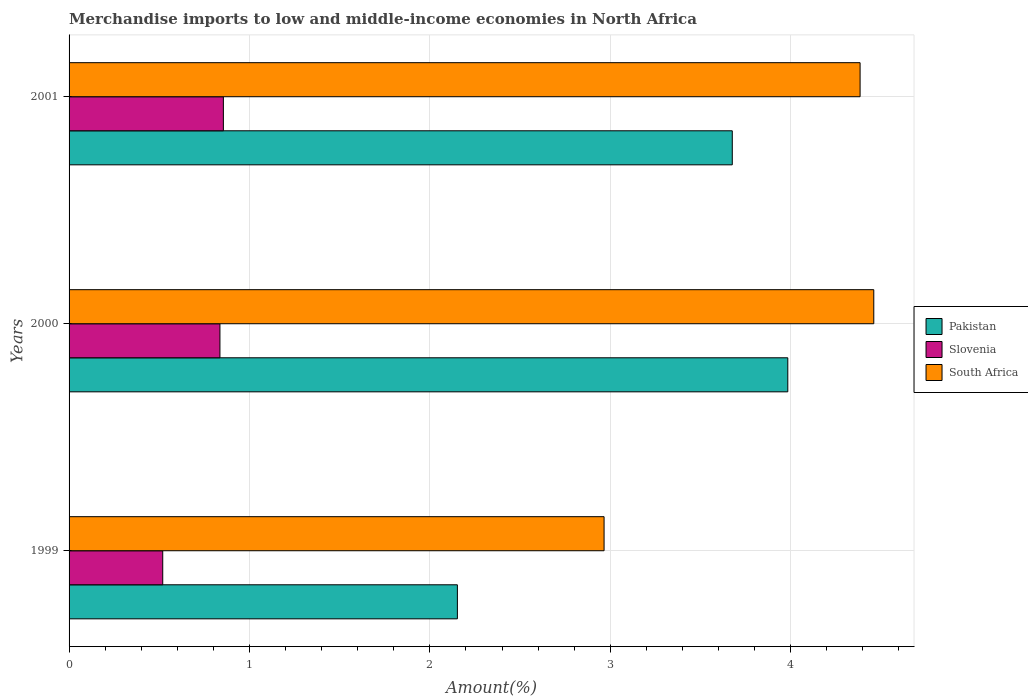How many groups of bars are there?
Offer a terse response. 3. Are the number of bars per tick equal to the number of legend labels?
Provide a short and direct response. Yes. How many bars are there on the 3rd tick from the bottom?
Provide a succinct answer. 3. What is the percentage of amount earned from merchandise imports in Slovenia in 2000?
Make the answer very short. 0.84. Across all years, what is the maximum percentage of amount earned from merchandise imports in Pakistan?
Offer a terse response. 3.98. Across all years, what is the minimum percentage of amount earned from merchandise imports in South Africa?
Provide a short and direct response. 2.97. In which year was the percentage of amount earned from merchandise imports in Slovenia maximum?
Your answer should be very brief. 2001. In which year was the percentage of amount earned from merchandise imports in Pakistan minimum?
Your answer should be compact. 1999. What is the total percentage of amount earned from merchandise imports in South Africa in the graph?
Your answer should be very brief. 11.81. What is the difference between the percentage of amount earned from merchandise imports in Slovenia in 1999 and that in 2001?
Offer a very short reply. -0.34. What is the difference between the percentage of amount earned from merchandise imports in Slovenia in 2000 and the percentage of amount earned from merchandise imports in South Africa in 2001?
Your answer should be compact. -3.55. What is the average percentage of amount earned from merchandise imports in Slovenia per year?
Provide a short and direct response. 0.74. In the year 1999, what is the difference between the percentage of amount earned from merchandise imports in Pakistan and percentage of amount earned from merchandise imports in South Africa?
Your response must be concise. -0.81. In how many years, is the percentage of amount earned from merchandise imports in South Africa greater than 1.6 %?
Provide a short and direct response. 3. What is the ratio of the percentage of amount earned from merchandise imports in Pakistan in 1999 to that in 2001?
Make the answer very short. 0.59. Is the percentage of amount earned from merchandise imports in Pakistan in 1999 less than that in 2001?
Provide a succinct answer. Yes. Is the difference between the percentage of amount earned from merchandise imports in Pakistan in 1999 and 2001 greater than the difference between the percentage of amount earned from merchandise imports in South Africa in 1999 and 2001?
Make the answer very short. No. What is the difference between the highest and the second highest percentage of amount earned from merchandise imports in Pakistan?
Offer a terse response. 0.31. What is the difference between the highest and the lowest percentage of amount earned from merchandise imports in Slovenia?
Your answer should be very brief. 0.34. What does the 1st bar from the top in 2001 represents?
Offer a terse response. South Africa. What does the 3rd bar from the bottom in 1999 represents?
Your answer should be very brief. South Africa. Is it the case that in every year, the sum of the percentage of amount earned from merchandise imports in South Africa and percentage of amount earned from merchandise imports in Pakistan is greater than the percentage of amount earned from merchandise imports in Slovenia?
Offer a very short reply. Yes. Are all the bars in the graph horizontal?
Give a very brief answer. Yes. How many years are there in the graph?
Ensure brevity in your answer.  3. Are the values on the major ticks of X-axis written in scientific E-notation?
Provide a succinct answer. No. Does the graph contain any zero values?
Provide a short and direct response. No. Does the graph contain grids?
Ensure brevity in your answer.  Yes. How are the legend labels stacked?
Ensure brevity in your answer.  Vertical. What is the title of the graph?
Offer a very short reply. Merchandise imports to low and middle-income economies in North Africa. Does "Paraguay" appear as one of the legend labels in the graph?
Your answer should be compact. No. What is the label or title of the X-axis?
Ensure brevity in your answer.  Amount(%). What is the Amount(%) of Pakistan in 1999?
Provide a short and direct response. 2.15. What is the Amount(%) of Slovenia in 1999?
Your response must be concise. 0.52. What is the Amount(%) in South Africa in 1999?
Offer a terse response. 2.97. What is the Amount(%) of Pakistan in 2000?
Give a very brief answer. 3.98. What is the Amount(%) in Slovenia in 2000?
Keep it short and to the point. 0.84. What is the Amount(%) of South Africa in 2000?
Offer a terse response. 4.46. What is the Amount(%) in Pakistan in 2001?
Give a very brief answer. 3.68. What is the Amount(%) in Slovenia in 2001?
Give a very brief answer. 0.86. What is the Amount(%) in South Africa in 2001?
Your response must be concise. 4.38. Across all years, what is the maximum Amount(%) in Pakistan?
Offer a very short reply. 3.98. Across all years, what is the maximum Amount(%) in Slovenia?
Provide a short and direct response. 0.86. Across all years, what is the maximum Amount(%) in South Africa?
Provide a short and direct response. 4.46. Across all years, what is the minimum Amount(%) in Pakistan?
Your response must be concise. 2.15. Across all years, what is the minimum Amount(%) in Slovenia?
Offer a very short reply. 0.52. Across all years, what is the minimum Amount(%) in South Africa?
Ensure brevity in your answer.  2.97. What is the total Amount(%) of Pakistan in the graph?
Provide a short and direct response. 9.81. What is the total Amount(%) in Slovenia in the graph?
Keep it short and to the point. 2.21. What is the total Amount(%) of South Africa in the graph?
Ensure brevity in your answer.  11.81. What is the difference between the Amount(%) in Pakistan in 1999 and that in 2000?
Your answer should be compact. -1.83. What is the difference between the Amount(%) in Slovenia in 1999 and that in 2000?
Provide a succinct answer. -0.32. What is the difference between the Amount(%) of South Africa in 1999 and that in 2000?
Offer a terse response. -1.49. What is the difference between the Amount(%) in Pakistan in 1999 and that in 2001?
Your answer should be compact. -1.52. What is the difference between the Amount(%) of Slovenia in 1999 and that in 2001?
Your answer should be compact. -0.34. What is the difference between the Amount(%) of South Africa in 1999 and that in 2001?
Your answer should be compact. -1.42. What is the difference between the Amount(%) of Pakistan in 2000 and that in 2001?
Your answer should be compact. 0.31. What is the difference between the Amount(%) of Slovenia in 2000 and that in 2001?
Your answer should be very brief. -0.02. What is the difference between the Amount(%) of South Africa in 2000 and that in 2001?
Provide a short and direct response. 0.08. What is the difference between the Amount(%) of Pakistan in 1999 and the Amount(%) of Slovenia in 2000?
Offer a very short reply. 1.32. What is the difference between the Amount(%) of Pakistan in 1999 and the Amount(%) of South Africa in 2000?
Provide a succinct answer. -2.31. What is the difference between the Amount(%) of Slovenia in 1999 and the Amount(%) of South Africa in 2000?
Offer a very short reply. -3.94. What is the difference between the Amount(%) in Pakistan in 1999 and the Amount(%) in Slovenia in 2001?
Provide a short and direct response. 1.3. What is the difference between the Amount(%) in Pakistan in 1999 and the Amount(%) in South Africa in 2001?
Ensure brevity in your answer.  -2.23. What is the difference between the Amount(%) in Slovenia in 1999 and the Amount(%) in South Africa in 2001?
Offer a very short reply. -3.87. What is the difference between the Amount(%) in Pakistan in 2000 and the Amount(%) in Slovenia in 2001?
Keep it short and to the point. 3.13. What is the difference between the Amount(%) of Pakistan in 2000 and the Amount(%) of South Africa in 2001?
Your answer should be very brief. -0.4. What is the difference between the Amount(%) in Slovenia in 2000 and the Amount(%) in South Africa in 2001?
Your response must be concise. -3.55. What is the average Amount(%) of Pakistan per year?
Keep it short and to the point. 3.27. What is the average Amount(%) in Slovenia per year?
Your answer should be compact. 0.74. What is the average Amount(%) of South Africa per year?
Give a very brief answer. 3.94. In the year 1999, what is the difference between the Amount(%) in Pakistan and Amount(%) in Slovenia?
Offer a very short reply. 1.63. In the year 1999, what is the difference between the Amount(%) in Pakistan and Amount(%) in South Africa?
Make the answer very short. -0.81. In the year 1999, what is the difference between the Amount(%) of Slovenia and Amount(%) of South Africa?
Your response must be concise. -2.45. In the year 2000, what is the difference between the Amount(%) in Pakistan and Amount(%) in Slovenia?
Give a very brief answer. 3.15. In the year 2000, what is the difference between the Amount(%) of Pakistan and Amount(%) of South Africa?
Provide a short and direct response. -0.48. In the year 2000, what is the difference between the Amount(%) in Slovenia and Amount(%) in South Africa?
Your answer should be very brief. -3.62. In the year 2001, what is the difference between the Amount(%) of Pakistan and Amount(%) of Slovenia?
Your answer should be very brief. 2.82. In the year 2001, what is the difference between the Amount(%) in Pakistan and Amount(%) in South Africa?
Make the answer very short. -0.71. In the year 2001, what is the difference between the Amount(%) in Slovenia and Amount(%) in South Africa?
Ensure brevity in your answer.  -3.53. What is the ratio of the Amount(%) in Pakistan in 1999 to that in 2000?
Your answer should be compact. 0.54. What is the ratio of the Amount(%) of Slovenia in 1999 to that in 2000?
Provide a succinct answer. 0.62. What is the ratio of the Amount(%) of South Africa in 1999 to that in 2000?
Make the answer very short. 0.66. What is the ratio of the Amount(%) in Pakistan in 1999 to that in 2001?
Ensure brevity in your answer.  0.59. What is the ratio of the Amount(%) in Slovenia in 1999 to that in 2001?
Your response must be concise. 0.61. What is the ratio of the Amount(%) in South Africa in 1999 to that in 2001?
Provide a short and direct response. 0.68. What is the ratio of the Amount(%) in Pakistan in 2000 to that in 2001?
Your response must be concise. 1.08. What is the ratio of the Amount(%) of Slovenia in 2000 to that in 2001?
Make the answer very short. 0.98. What is the ratio of the Amount(%) of South Africa in 2000 to that in 2001?
Your answer should be compact. 1.02. What is the difference between the highest and the second highest Amount(%) of Pakistan?
Offer a terse response. 0.31. What is the difference between the highest and the second highest Amount(%) in Slovenia?
Your answer should be compact. 0.02. What is the difference between the highest and the second highest Amount(%) of South Africa?
Your response must be concise. 0.08. What is the difference between the highest and the lowest Amount(%) in Pakistan?
Offer a very short reply. 1.83. What is the difference between the highest and the lowest Amount(%) in Slovenia?
Make the answer very short. 0.34. What is the difference between the highest and the lowest Amount(%) in South Africa?
Ensure brevity in your answer.  1.49. 